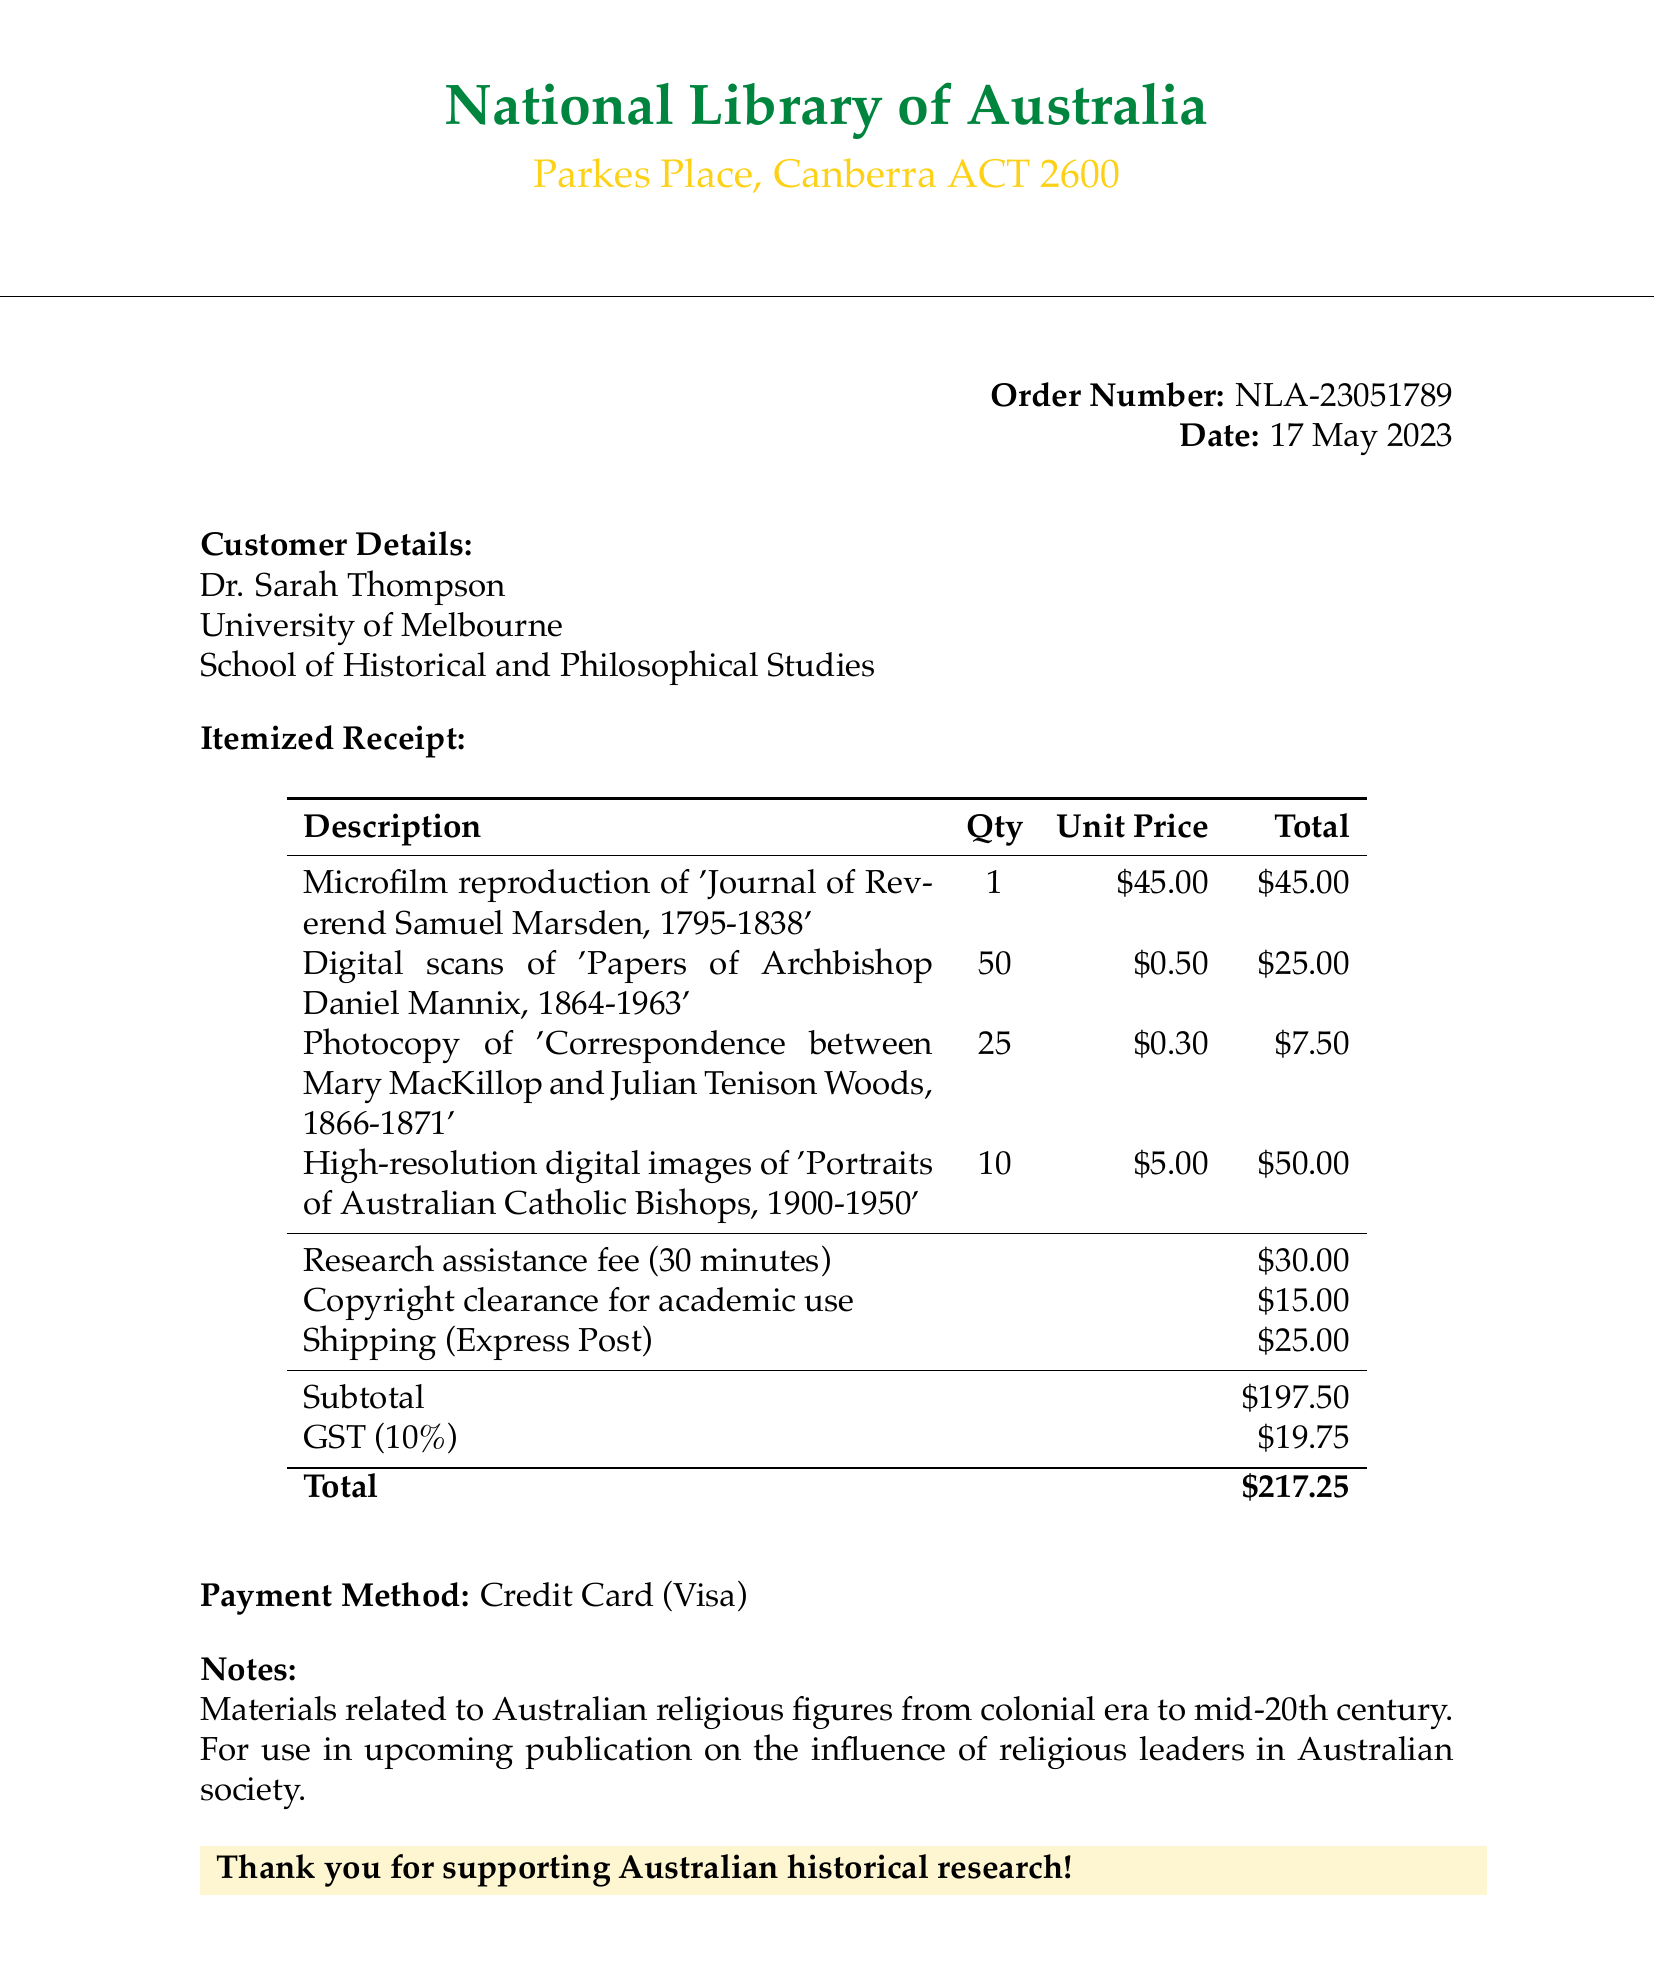What is the customer's name? The customer's name is mentioned under customer details in the document.
Answer: Dr. Sarah Thompson What is the order number? The order number is provided in a bold font, making it easy to locate.
Answer: NLA-23051789 What is the total cost of the items before tax? The subtotal reflects the total cost before tax, as shown in the receipt.
Answer: 197.50 How many photocopies were ordered? The quantity for photocopies is specified in the itemized section of the receipt.
Answer: 25 What is the shipping method used? The shipping method is specifically stated in the shipping information.
Answer: Express Post What is the amount charged for research assistance? The fee for research assistance is listed in the fees section of the receipt.
Answer: 30.00 How many digital scans of the papers were ordered? The document lists the quantity of digital scans as part of the itemized receipt.
Answer: 50 What is the GST amount charged? The GST amount is noted distinctly in the calculation section of the receipt.
Answer: 19.75 What institution is Dr. Sarah Thompson affiliated with? The institution is stated in the customer details section of the receipt.
Answer: University of Melbourne 